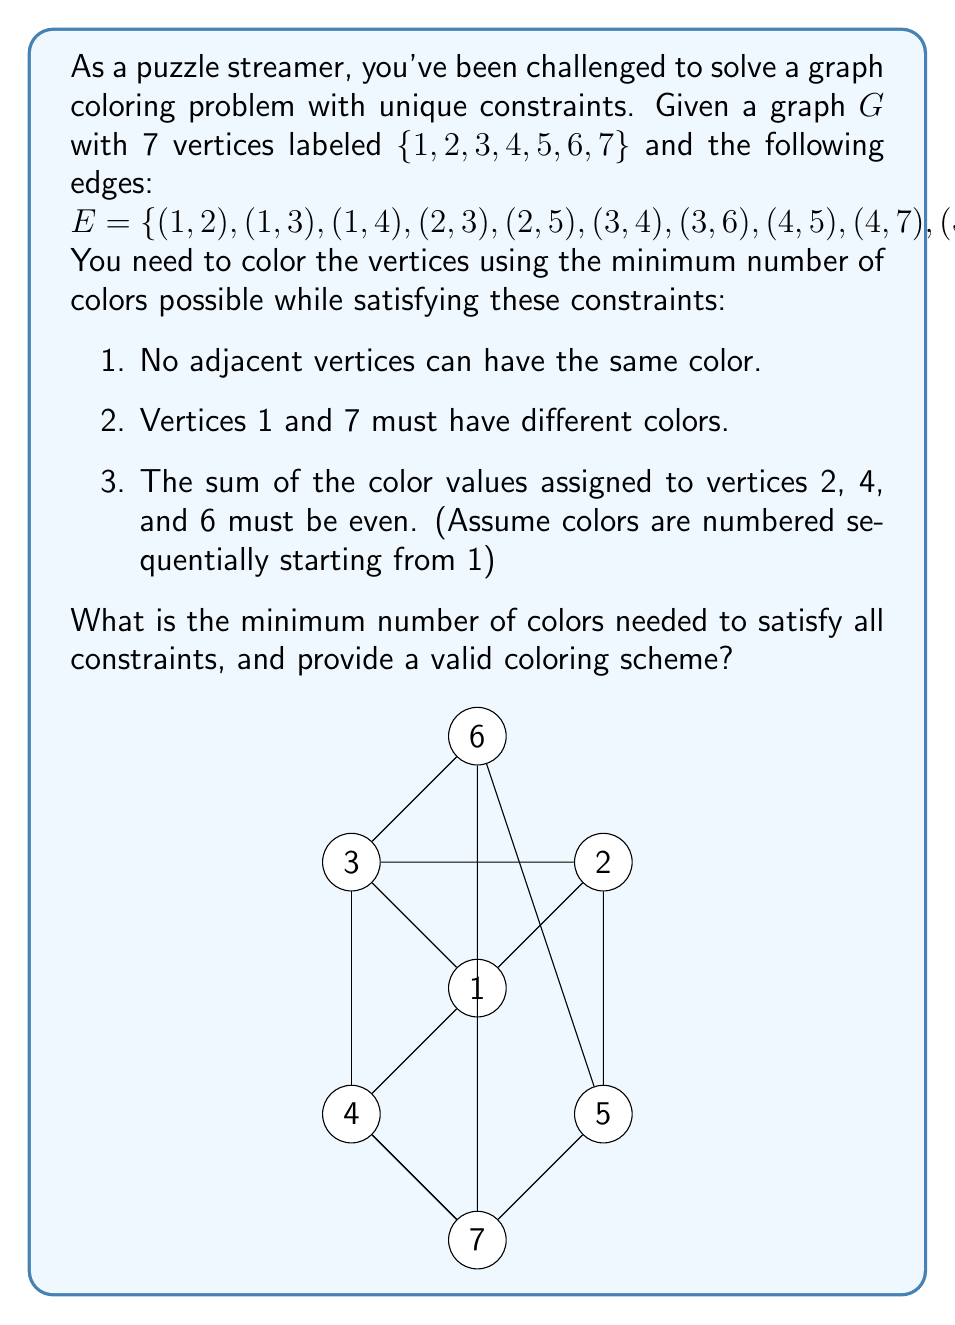Solve this math problem. Let's approach this problem step by step:

1) First, we need to determine the chromatic number of the graph without considering the additional constraints. The graph has a maximum clique of size 4 (vertices 1, 2, 3, 4 form a clique), so we need at least 4 colors.

2) Now, let's consider the additional constraints:
   a) Vertices 1 and 7 must have different colors.
   b) The sum of color values for vertices 2, 4, and 6 must be even.

3) Let's start coloring:
   - Assign color 1 to vertex 1.
   - Vertices 2, 3, and 4 must all have different colors. Let's assign 2, 3, and 4 respectively.
   - Vertex 5 is adjacent to 2 and 4, so it can be colored 1 or 3. Let's choose 3.
   - Vertex 6 is adjacent to 3 and 5, so it can be colored 1, 2, or 4. We need to choose carefully to satisfy constraint b. Let's choose 2.
   - Vertex 7 is adjacent to 4 and 5, and must be different from 1. It can be colored 2 or 3. Let's choose 2.

4) Let's check our constraints:
   a) Vertices 1 and 7 have different colors (1 and 2).
   b) The sum of colors for vertices 2, 4, and 6 is 2 + 4 + 2 = 8, which is even.

5) Therefore, we can color the graph using 4 colors while satisfying all constraints.

The coloring scheme is:
1: 1
2: 2
3: 3
4: 4
5: 3
6: 2
7: 2
Answer: The minimum number of colors needed is 4. A valid coloring scheme is:
$c(1) = 1, c(2) = 2, c(3) = 3, c(4) = 4, c(5) = 3, c(6) = 2, c(7) = 2$ 